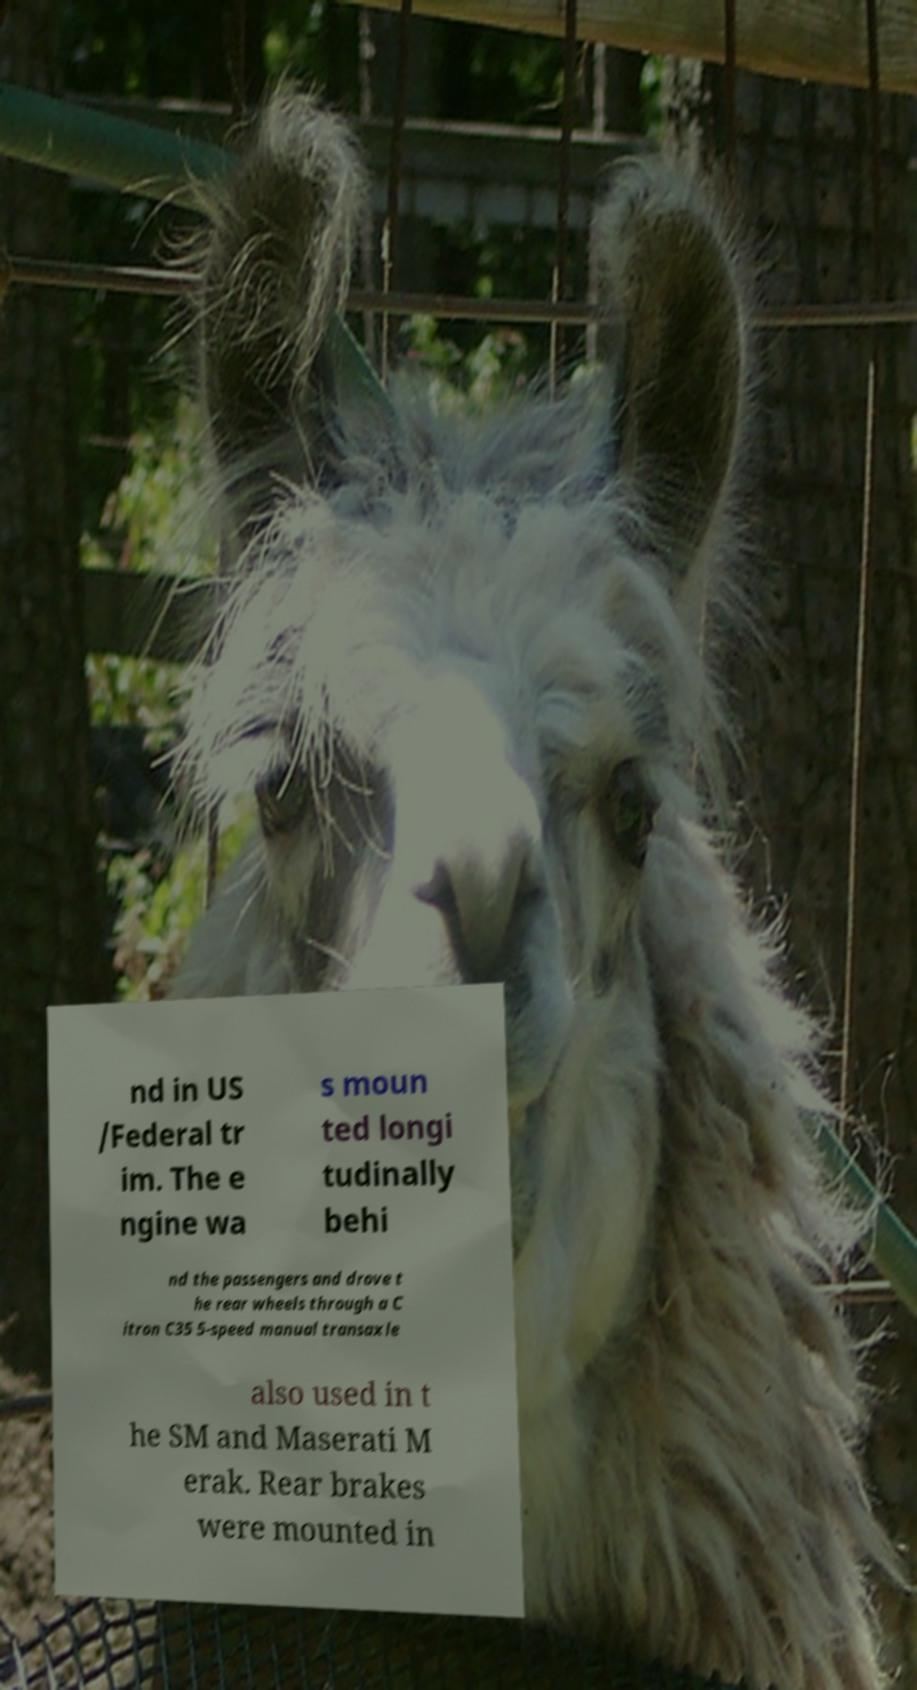What messages or text are displayed in this image? I need them in a readable, typed format. nd in US /Federal tr im. The e ngine wa s moun ted longi tudinally behi nd the passengers and drove t he rear wheels through a C itron C35 5-speed manual transaxle also used in t he SM and Maserati M erak. Rear brakes were mounted in 